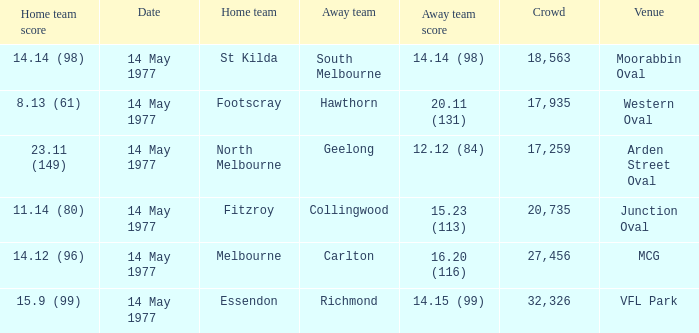I want to know the home team score of the away team of richmond that has a crowd more than 20,735 15.9 (99). 